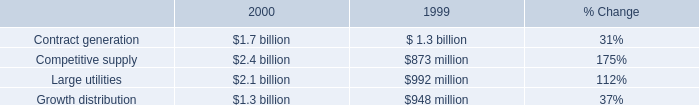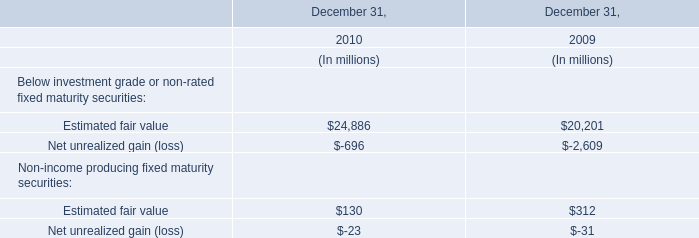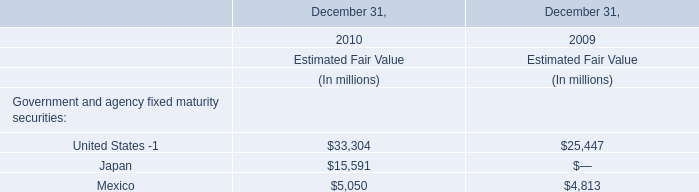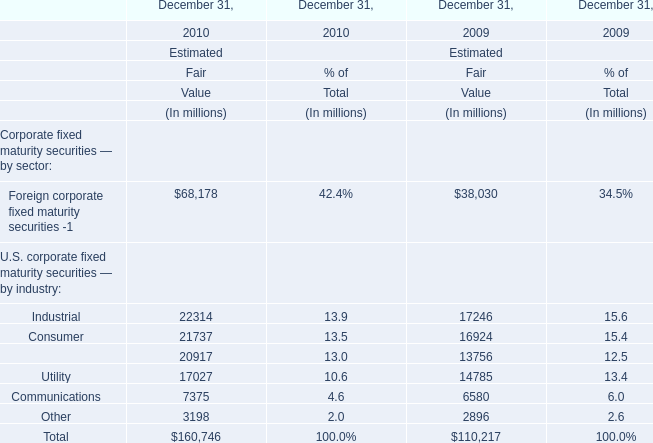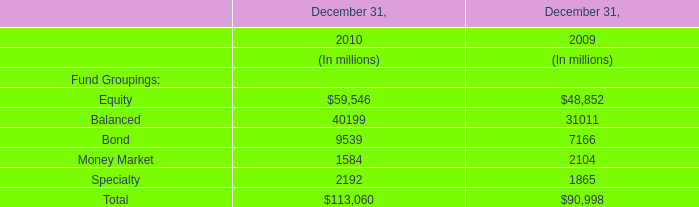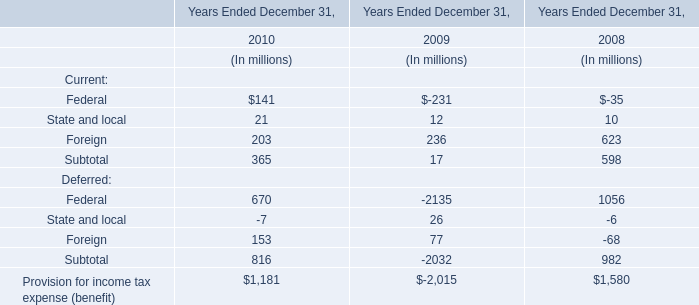In the year with largest amount of Foreign corporate fixed maturity securities -1 what's the sum ofIndustrial and Consumer ? (in million) 
Computations: (22314 + 21737)
Answer: 44051.0. 